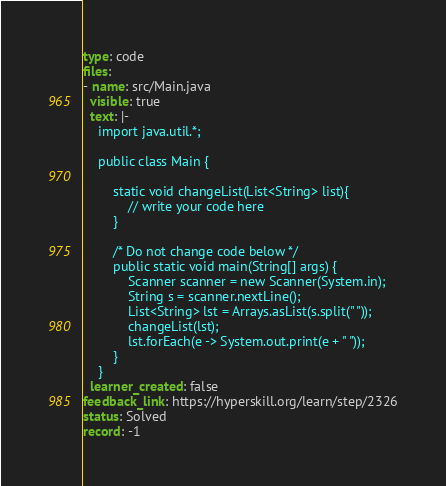<code> <loc_0><loc_0><loc_500><loc_500><_YAML_>type: code
files:
- name: src/Main.java
  visible: true
  text: |-
    import java.util.*;

    public class Main {

        static void changeList(List<String> list){
            // write your code here
        }

        /* Do not change code below */
        public static void main(String[] args) {
            Scanner scanner = new Scanner(System.in);
            String s = scanner.nextLine();
            List<String> lst = Arrays.asList(s.split(" "));
            changeList(lst);
            lst.forEach(e -> System.out.print(e + " "));
        }
    }
  learner_created: false
feedback_link: https://hyperskill.org/learn/step/2326
status: Solved
record: -1
</code> 